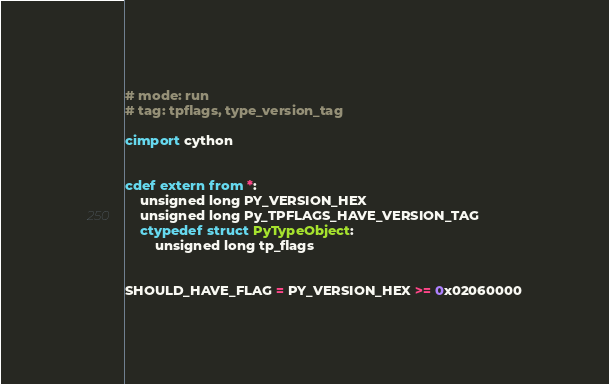Convert code to text. <code><loc_0><loc_0><loc_500><loc_500><_Cython_># mode: run
# tag: tpflags, type_version_tag

cimport cython


cdef extern from *:
    unsigned long PY_VERSION_HEX
    unsigned long Py_TPFLAGS_HAVE_VERSION_TAG
    ctypedef struct PyTypeObject:
        unsigned long tp_flags


SHOULD_HAVE_FLAG = PY_VERSION_HEX >= 0x02060000

</code> 